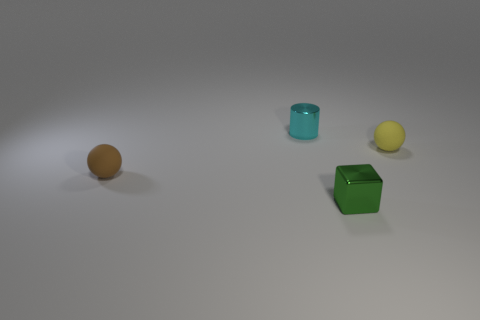Besides the brown cube, what other shapes can be seen in this image? Besides the brown cube, there are three additional distinct shapes: a yellow spherical ball, a green cube with more rounded edges and corners, and a cylinder that is teal in color. These shapes together form a simple yet visually engaging collection of geometric forms, reminiscent of basic shape-sorting toys. Are there different textures on these shapes? Yes, there are subtle differences in texture among the shapes. The yellow ball seems to have a slightly textured surface, possibly for grip, as seen in sports balls. The green cube and brown cube both appear quite smooth, indicating a hard, perhaps plastic-like material. The teal cylinder has the glossiest finish among them, reflecting more light and giving it a slick appearance. 